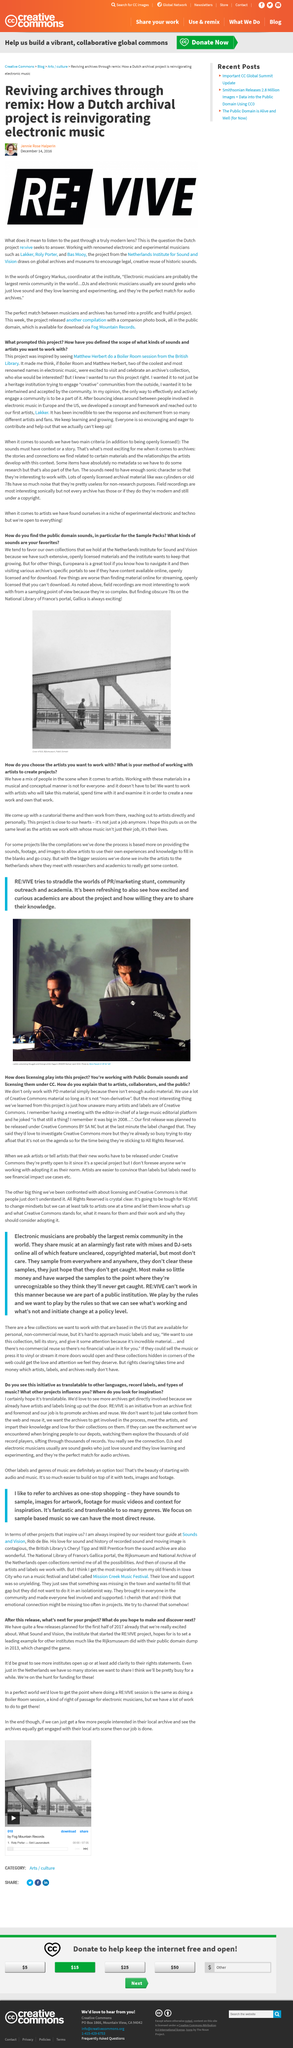Outline some significant characteristics in this image. The three renowned electronic and experimental musicians mentioned are Lakker, Roly Porter, and Bas Mooy. Jennie Rose Halperin is the author of this article. The Netherlands Institute for Sound and Vision's coordinator is named Gregory Markus. 